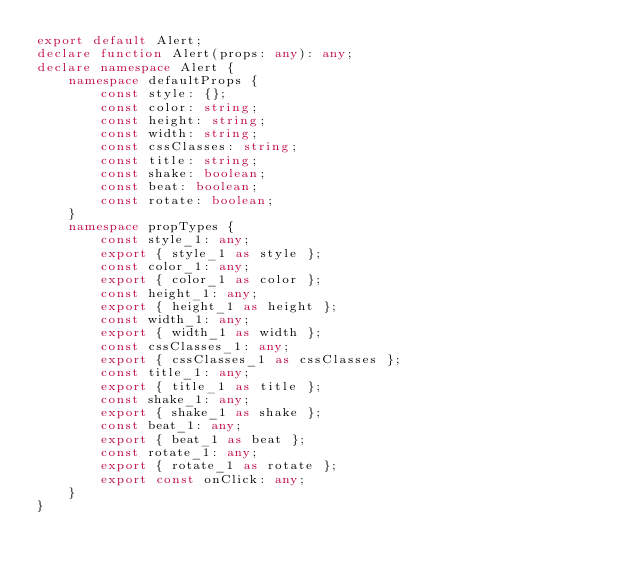Convert code to text. <code><loc_0><loc_0><loc_500><loc_500><_TypeScript_>export default Alert;
declare function Alert(props: any): any;
declare namespace Alert {
    namespace defaultProps {
        const style: {};
        const color: string;
        const height: string;
        const width: string;
        const cssClasses: string;
        const title: string;
        const shake: boolean;
        const beat: boolean;
        const rotate: boolean;
    }
    namespace propTypes {
        const style_1: any;
        export { style_1 as style };
        const color_1: any;
        export { color_1 as color };
        const height_1: any;
        export { height_1 as height };
        const width_1: any;
        export { width_1 as width };
        const cssClasses_1: any;
        export { cssClasses_1 as cssClasses };
        const title_1: any;
        export { title_1 as title };
        const shake_1: any;
        export { shake_1 as shake };
        const beat_1: any;
        export { beat_1 as beat };
        const rotate_1: any;
        export { rotate_1 as rotate };
        export const onClick: any;
    }
}
</code> 